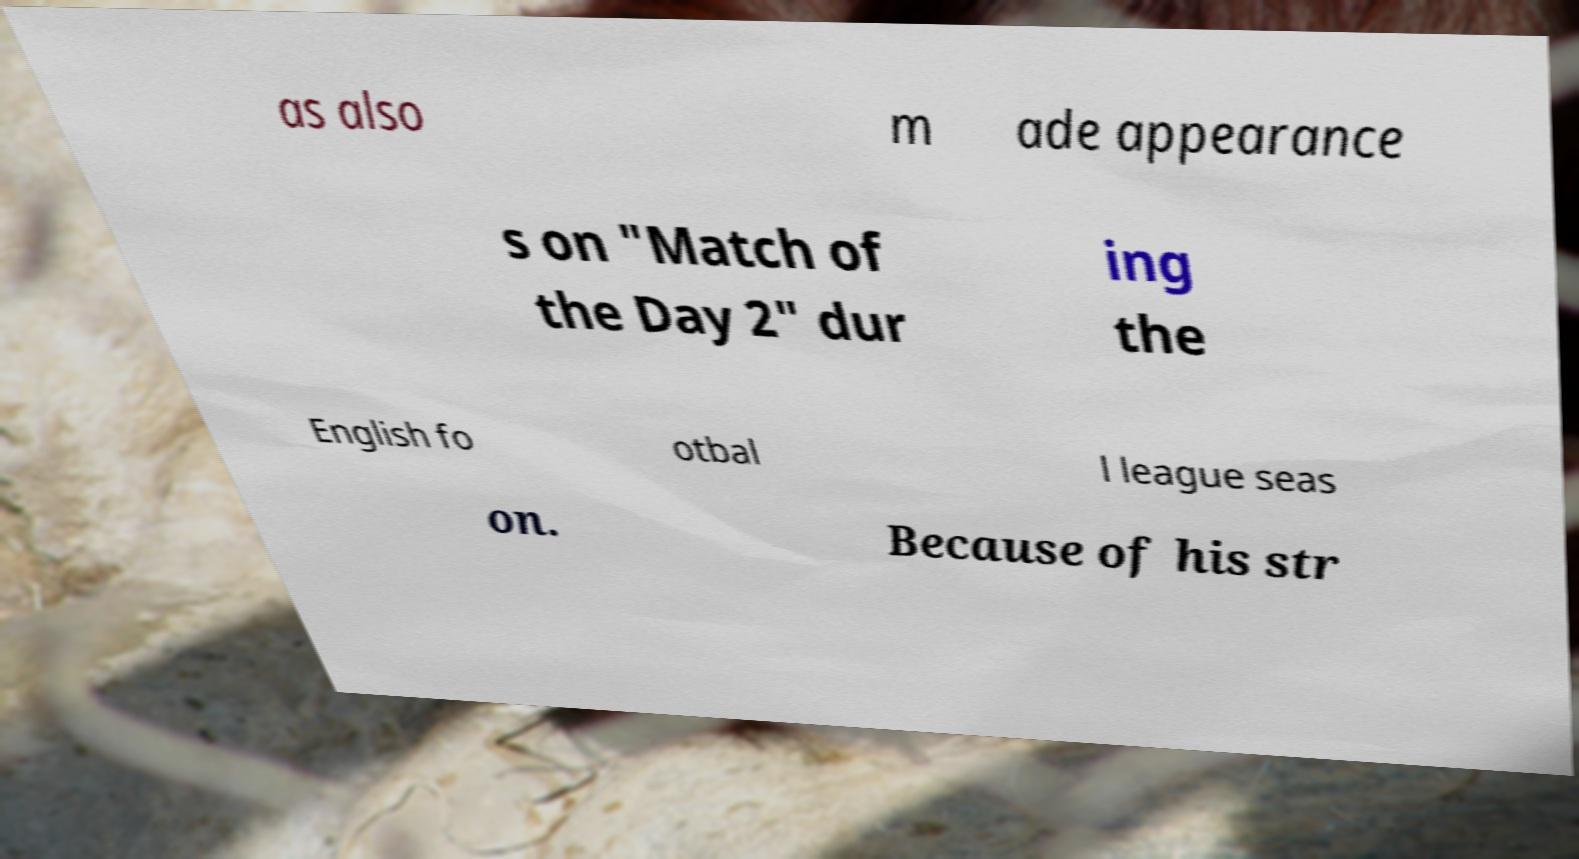For documentation purposes, I need the text within this image transcribed. Could you provide that? as also m ade appearance s on "Match of the Day 2" dur ing the English fo otbal l league seas on. Because of his str 